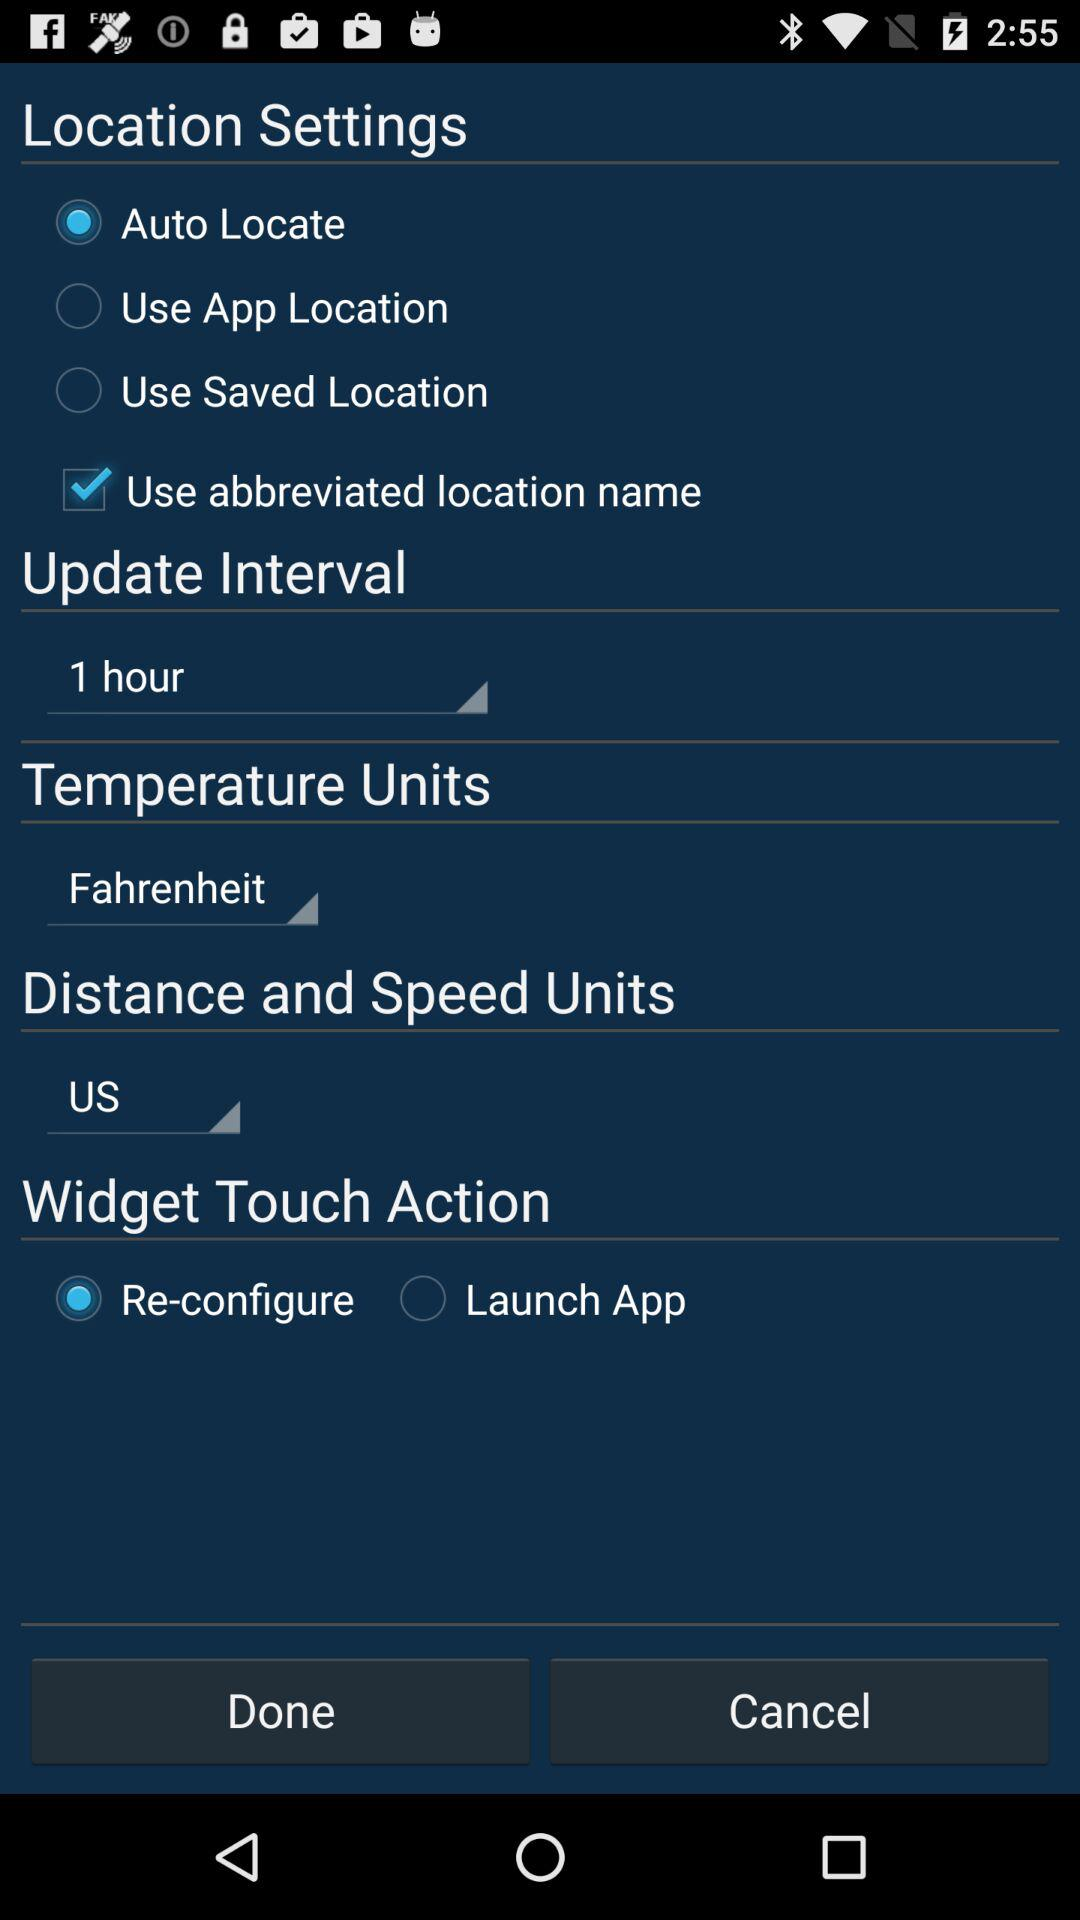What is the set update interval? The set update interval is 1 hour. 